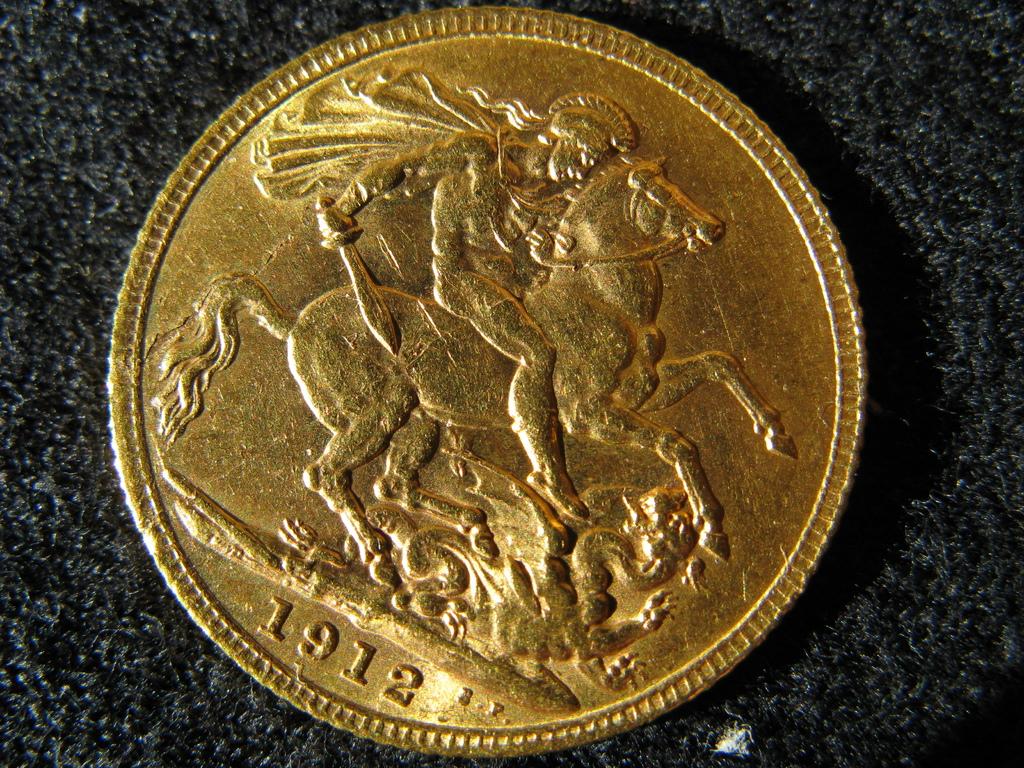What year was this coin made?
Make the answer very short. 1912. 